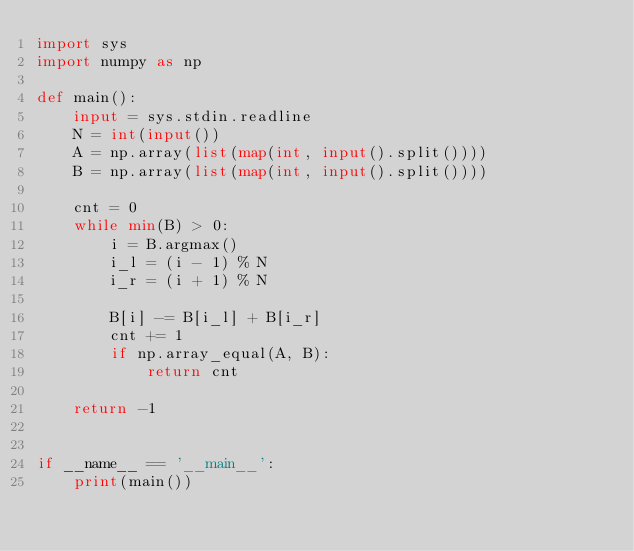Convert code to text. <code><loc_0><loc_0><loc_500><loc_500><_Python_>import sys
import numpy as np

def main():
    input = sys.stdin.readline
    N = int(input())
    A = np.array(list(map(int, input().split())))
    B = np.array(list(map(int, input().split())))

    cnt = 0
    while min(B) > 0:
        i = B.argmax()
        i_l = (i - 1) % N
        i_r = (i + 1) % N

        B[i] -= B[i_l] + B[i_r]
        cnt += 1
        if np.array_equal(A, B):
            return cnt

    return -1


if __name__ == '__main__':
    print(main())
</code> 